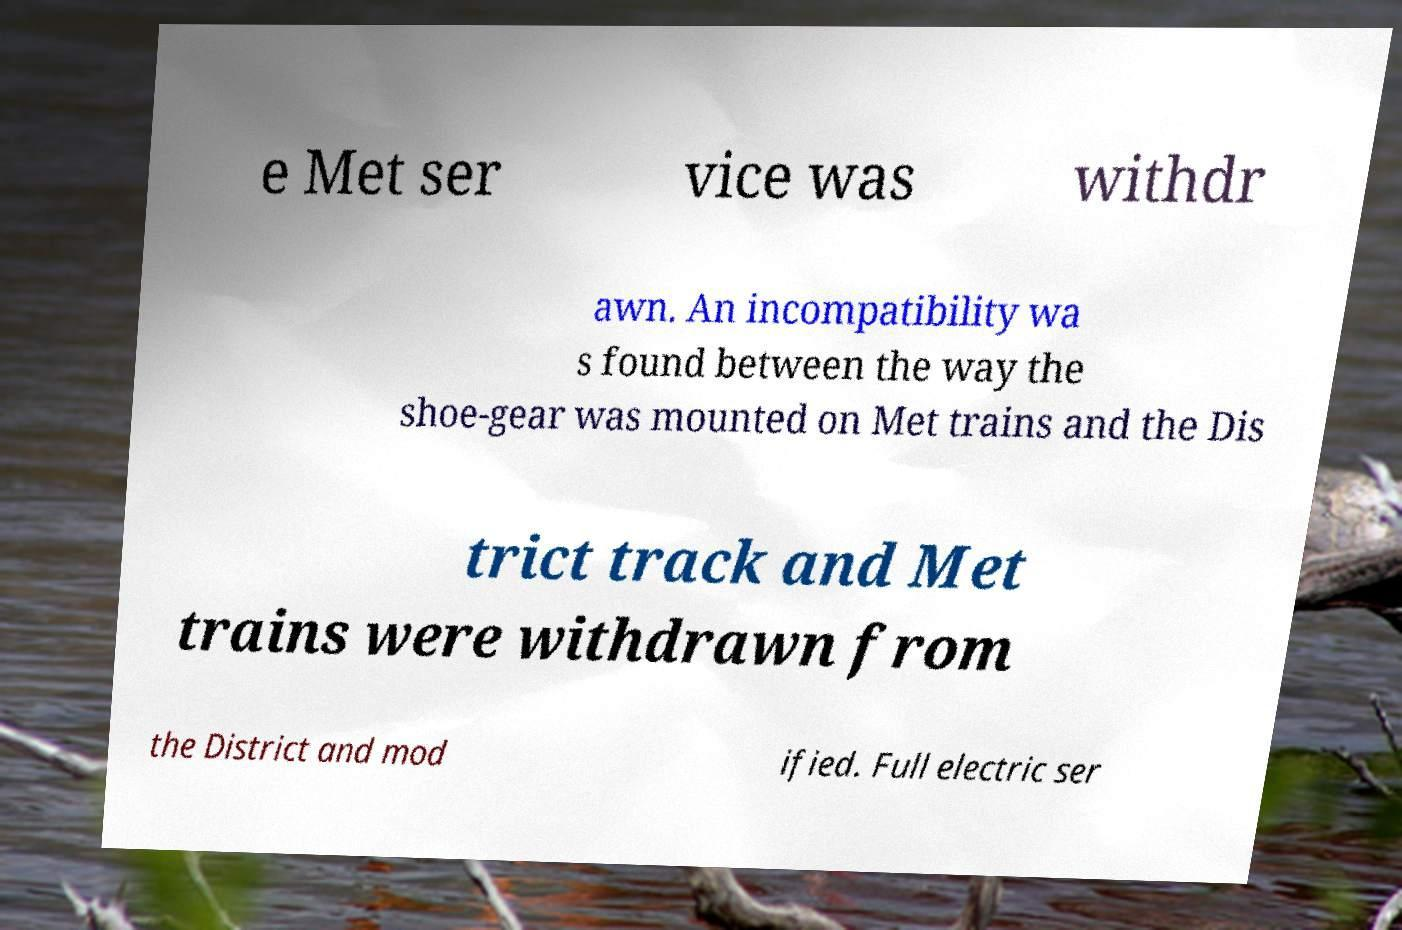I need the written content from this picture converted into text. Can you do that? e Met ser vice was withdr awn. An incompatibility wa s found between the way the shoe-gear was mounted on Met trains and the Dis trict track and Met trains were withdrawn from the District and mod ified. Full electric ser 